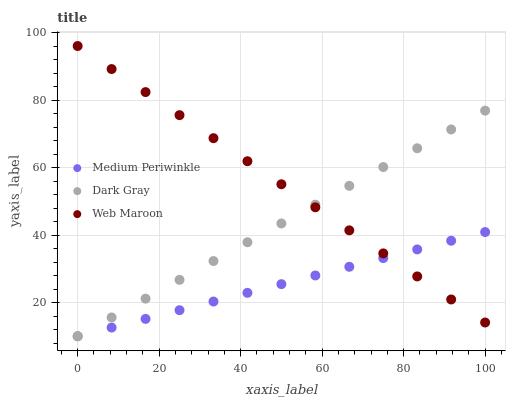Does Medium Periwinkle have the minimum area under the curve?
Answer yes or no. Yes. Does Web Maroon have the maximum area under the curve?
Answer yes or no. Yes. Does Web Maroon have the minimum area under the curve?
Answer yes or no. No. Does Medium Periwinkle have the maximum area under the curve?
Answer yes or no. No. Is Medium Periwinkle the smoothest?
Answer yes or no. Yes. Is Web Maroon the roughest?
Answer yes or no. Yes. Is Web Maroon the smoothest?
Answer yes or no. No. Is Medium Periwinkle the roughest?
Answer yes or no. No. Does Dark Gray have the lowest value?
Answer yes or no. Yes. Does Web Maroon have the lowest value?
Answer yes or no. No. Does Web Maroon have the highest value?
Answer yes or no. Yes. Does Medium Periwinkle have the highest value?
Answer yes or no. No. Does Medium Periwinkle intersect Dark Gray?
Answer yes or no. Yes. Is Medium Periwinkle less than Dark Gray?
Answer yes or no. No. Is Medium Periwinkle greater than Dark Gray?
Answer yes or no. No. 